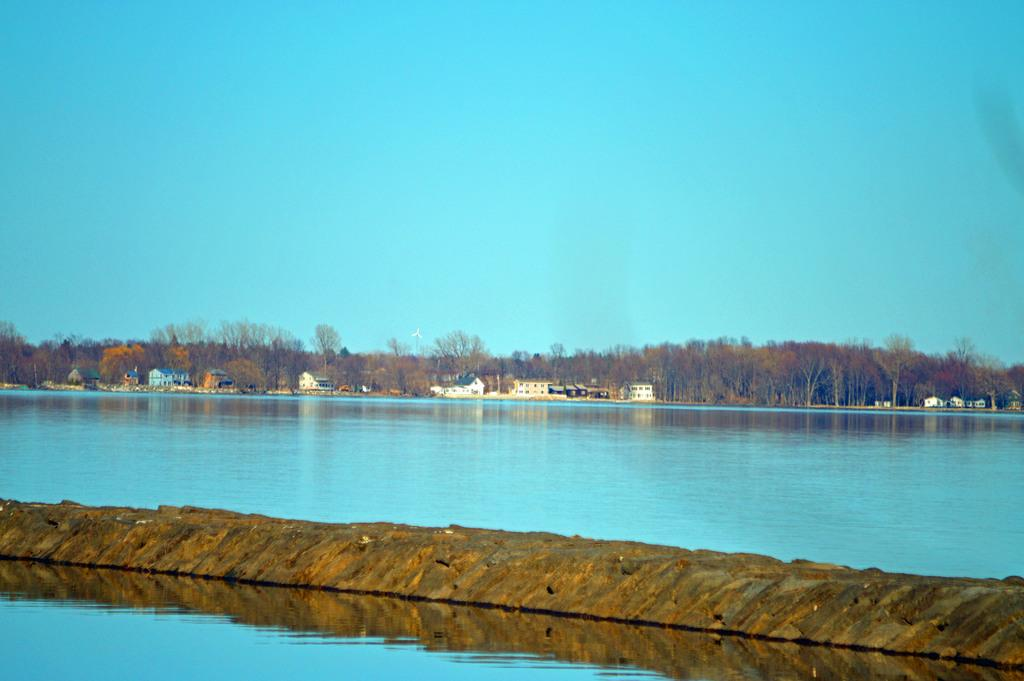What is visible at the bottom of the image? There is water visible at the bottom of the image. What is located near the water in the image? There is a platform near the water. What can be seen in the background of the image? In the background of the image, there is water, trees, houses, and the sky. Can you tell me how many times the porter tried to carry the water in the image? There is no porter present in the image, and therefore no such attempt can be observed. What type of partner is shown interacting with the water in the image? There is no partner present in the image; only the water, platform, and background elements are visible. 